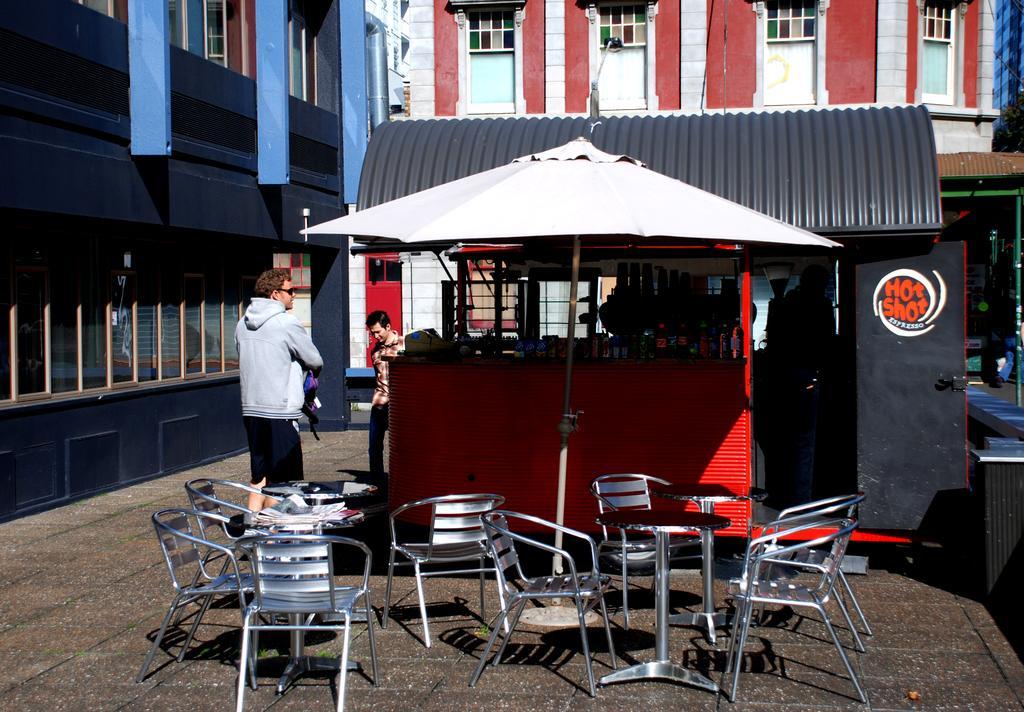Could you give a brief overview of what you see in this image? On the background we can see buildings with windows. Here we can see one store. In Front of a store we can see few chairs and tables. We can see two persons standing near to the store. 